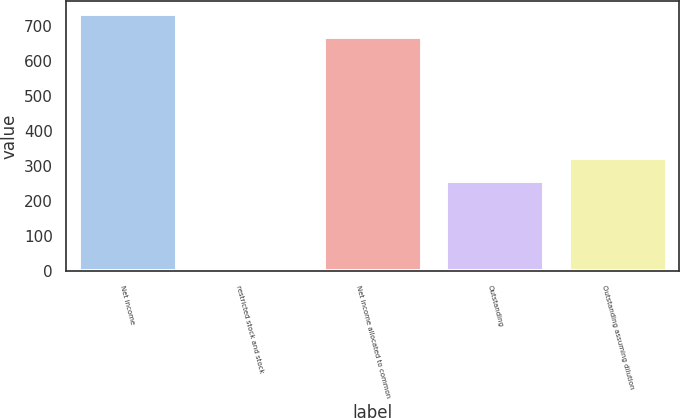<chart> <loc_0><loc_0><loc_500><loc_500><bar_chart><fcel>Net income<fcel>restricted stock and stock<fcel>Net income allocated to common<fcel>Outstanding<fcel>Outstanding assuming dilution<nl><fcel>736.34<fcel>2.8<fcel>669.4<fcel>257.2<fcel>324.14<nl></chart> 